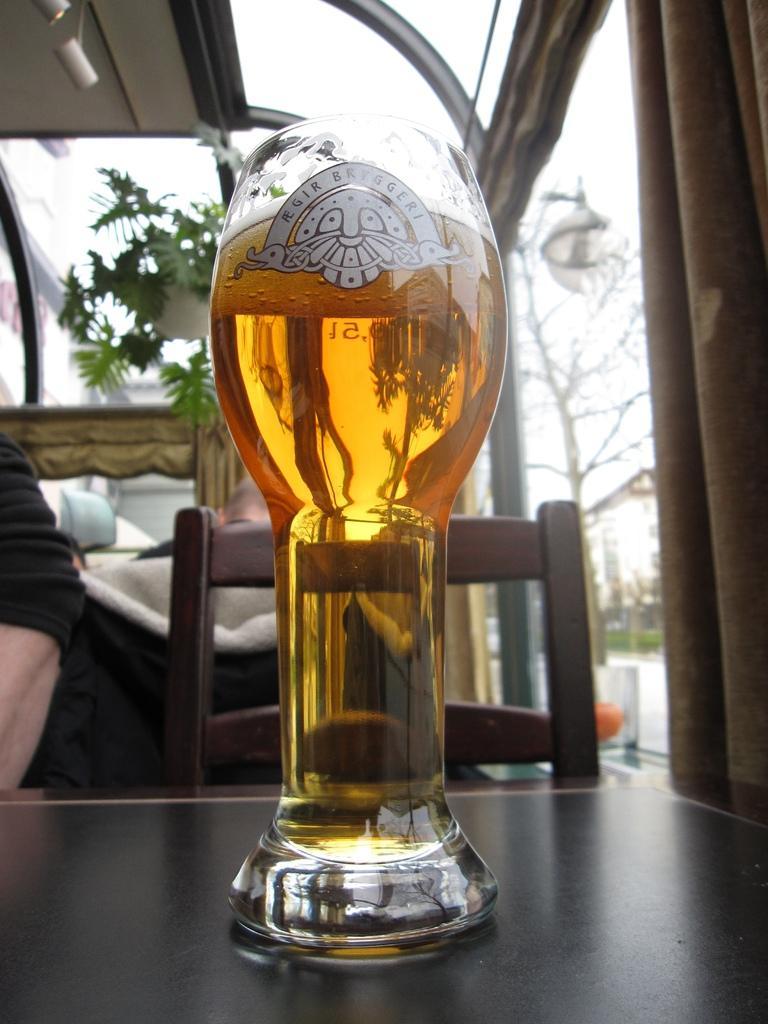Describe this image in one or two sentences. In this image I can see the glass on the table. In the background I can see few people and the chair and I can also see the plant in green color and the sky is in white color. 